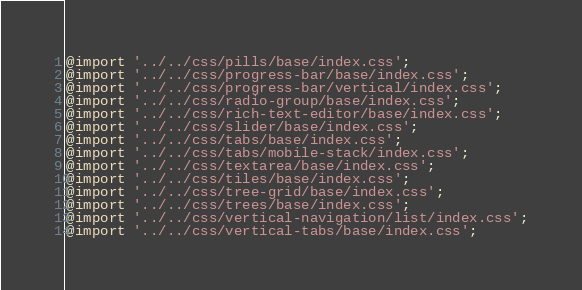Convert code to text. <code><loc_0><loc_0><loc_500><loc_500><_CSS_>@import '../../css/pills/base/index.css';
@import '../../css/progress-bar/base/index.css';
@import '../../css/progress-bar/vertical/index.css';
@import '../../css/radio-group/base/index.css';
@import '../../css/rich-text-editor/base/index.css';
@import '../../css/slider/base/index.css';
@import '../../css/tabs/base/index.css';
@import '../../css/tabs/mobile-stack/index.css';
@import '../../css/textarea/base/index.css';
@import '../../css/tiles/base/index.css';
@import '../../css/tree-grid/base/index.css';
@import '../../css/trees/base/index.css';
@import '../../css/vertical-navigation/list/index.css';
@import '../../css/vertical-tabs/base/index.css';
</code> 